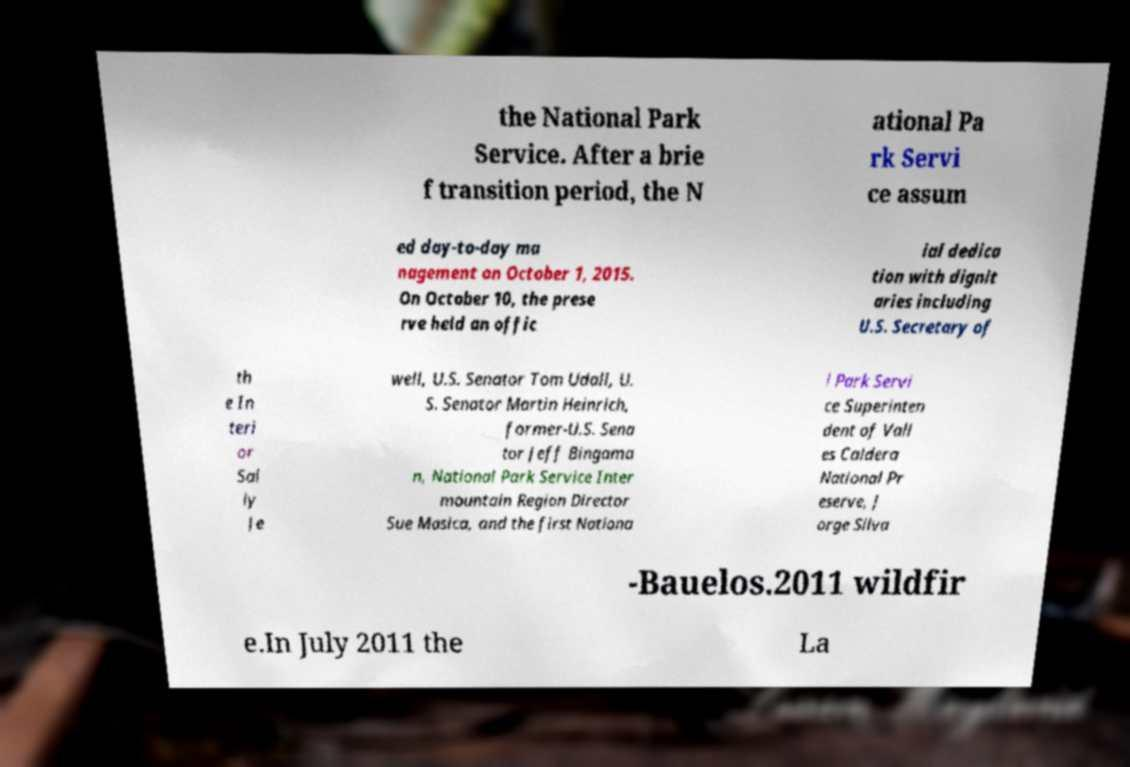Could you assist in decoding the text presented in this image and type it out clearly? the National Park Service. After a brie f transition period, the N ational Pa rk Servi ce assum ed day-to-day ma nagement on October 1, 2015. On October 10, the prese rve held an offic ial dedica tion with dignit aries including U.S. Secretary of th e In teri or Sal ly Je well, U.S. Senator Tom Udall, U. S. Senator Martin Heinrich, former-U.S. Sena tor Jeff Bingama n, National Park Service Inter mountain Region Director Sue Masica, and the first Nationa l Park Servi ce Superinten dent of Vall es Caldera National Pr eserve, J orge Silva -Bauelos.2011 wildfir e.In July 2011 the La 